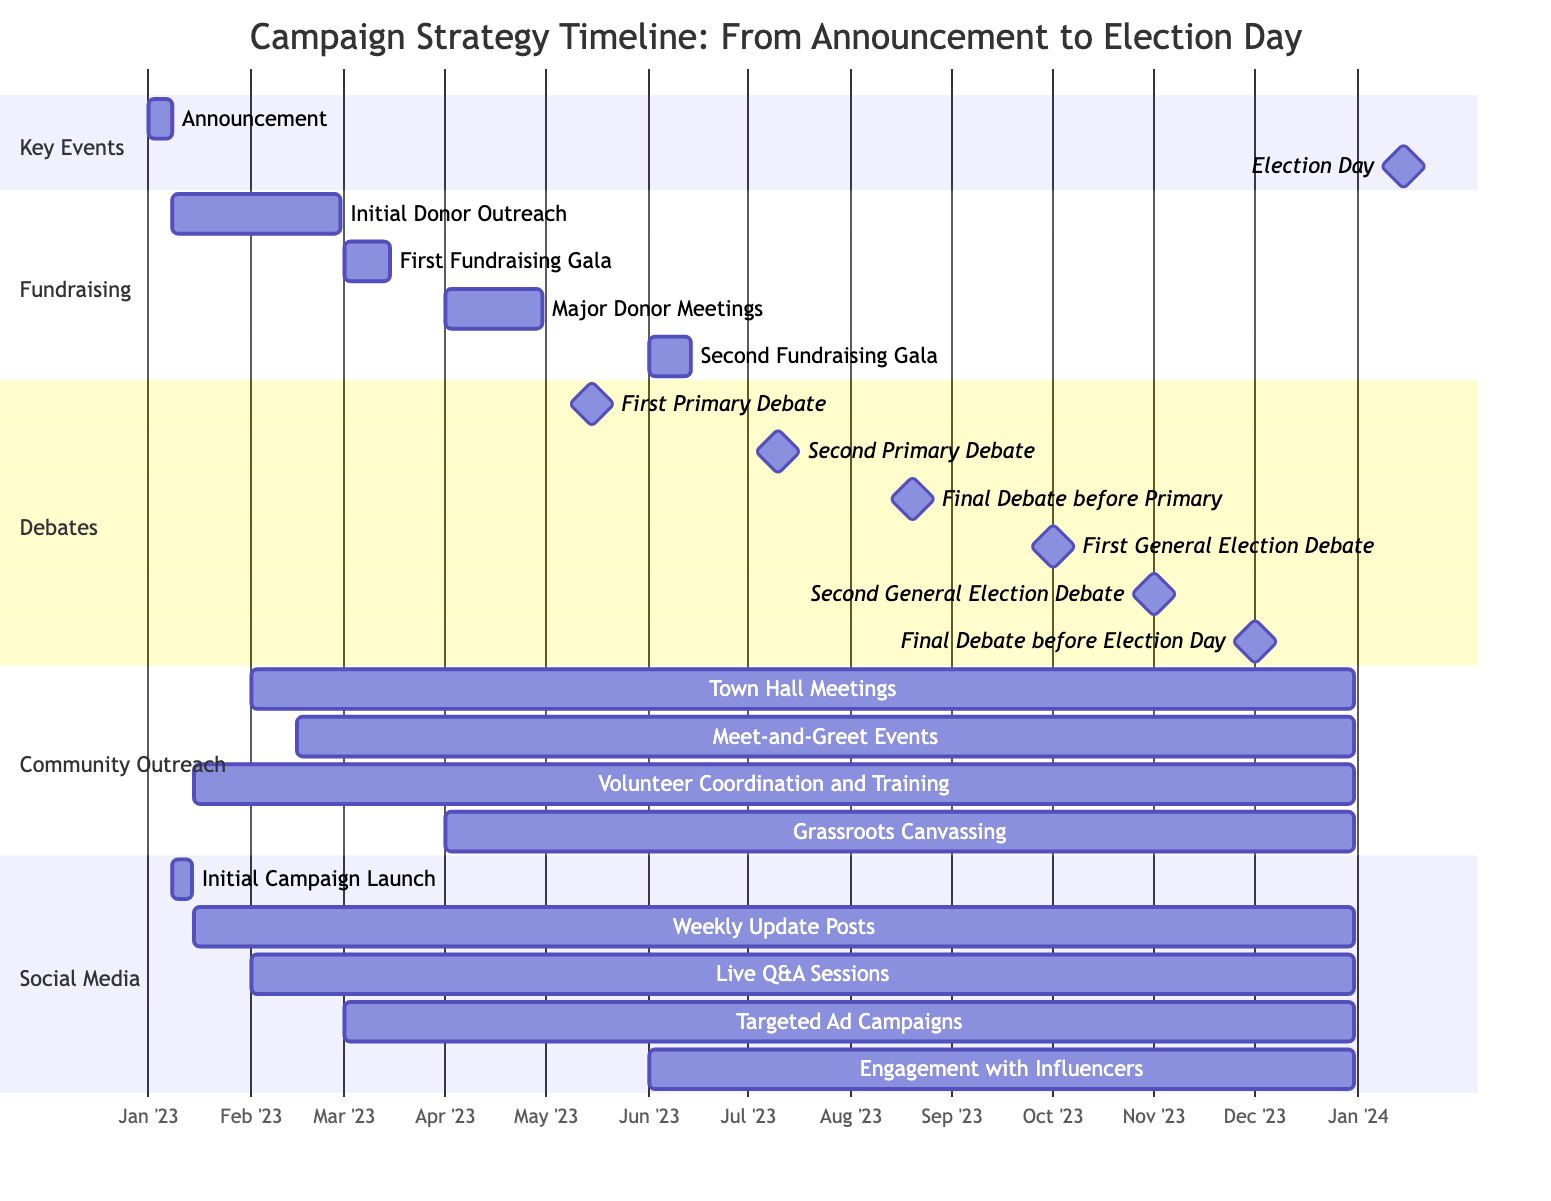What is the duration of the "Initial Donor Outreach"? The "Initial Donor Outreach" runs from January 8, 2023, to February 28, 2023. To find the duration, we can subtract the start date from the end date, resulting in 51 days.
Answer: 51 days What event occurs just before the "Final Debate before Election Day"? The "Final Debate before Election Day" is scheduled for December 1, 2023. To determine what event occurs just before it, we can look at the dates and find that the "Second General Election Debate" takes place on November 1, 2023, which is the event that immediately precedes December 1.
Answer: Second General Election Debate How many fundraising milestones are there? The diagram lists four fundraising milestones: "Initial Donor Outreach," "First Fundraising Gala," "Major Donor Meetings," and "Second Fundraising Gala." By counting these, we arrive at a total of four milestones.
Answer: 4 What is the end date of the "Grassroots Canvassing"? "Grassroots Canvassing" is scheduled to take place from April 1, 2023, to December 31, 2023. Thus, the end date of this event is December 31, 2023.
Answer: December 31, 2023 Which event has overlapping dates with "Town Hall Meetings"? "Town Hall Meetings" begin on February 1, 2023, and continue until December 31, 2023. The event "Meet-and-Greet Events" starts on February 15, 2023, and also ends on December 31, 2023, causing them to overlap during their run. Therefore, "Meet-and-Greet Events" is the answer since it falls within the same time frame.
Answer: Meet-and-Greet Events When is the "First General Election Debate" scheduled? The "First General Election Debate" is scheduled for October 1, 2023. This information can be directly referenced from the diagram where the date is clearly indicated next to the event.
Answer: October 1, 2023 What event starts right after the "Weekly Update Posts"? The "Weekly Update Posts" run from January 15, 2023, to December 31, 2023. Following this, the "Live Q&A Sessions" commence on February 1, 2023, which is the event that begins right after the "Weekly Update Posts" based on the start date.
Answer: Live Q&A Sessions How long does the "Volunteer Coordination and Training" last? The "Volunteer Coordination and Training" starts on January 15, 2023, and ends on December 31, 2023. To calculate the length, we can see it spans from mid-January to the end of December, which totals 351 days.
Answer: 351 days 